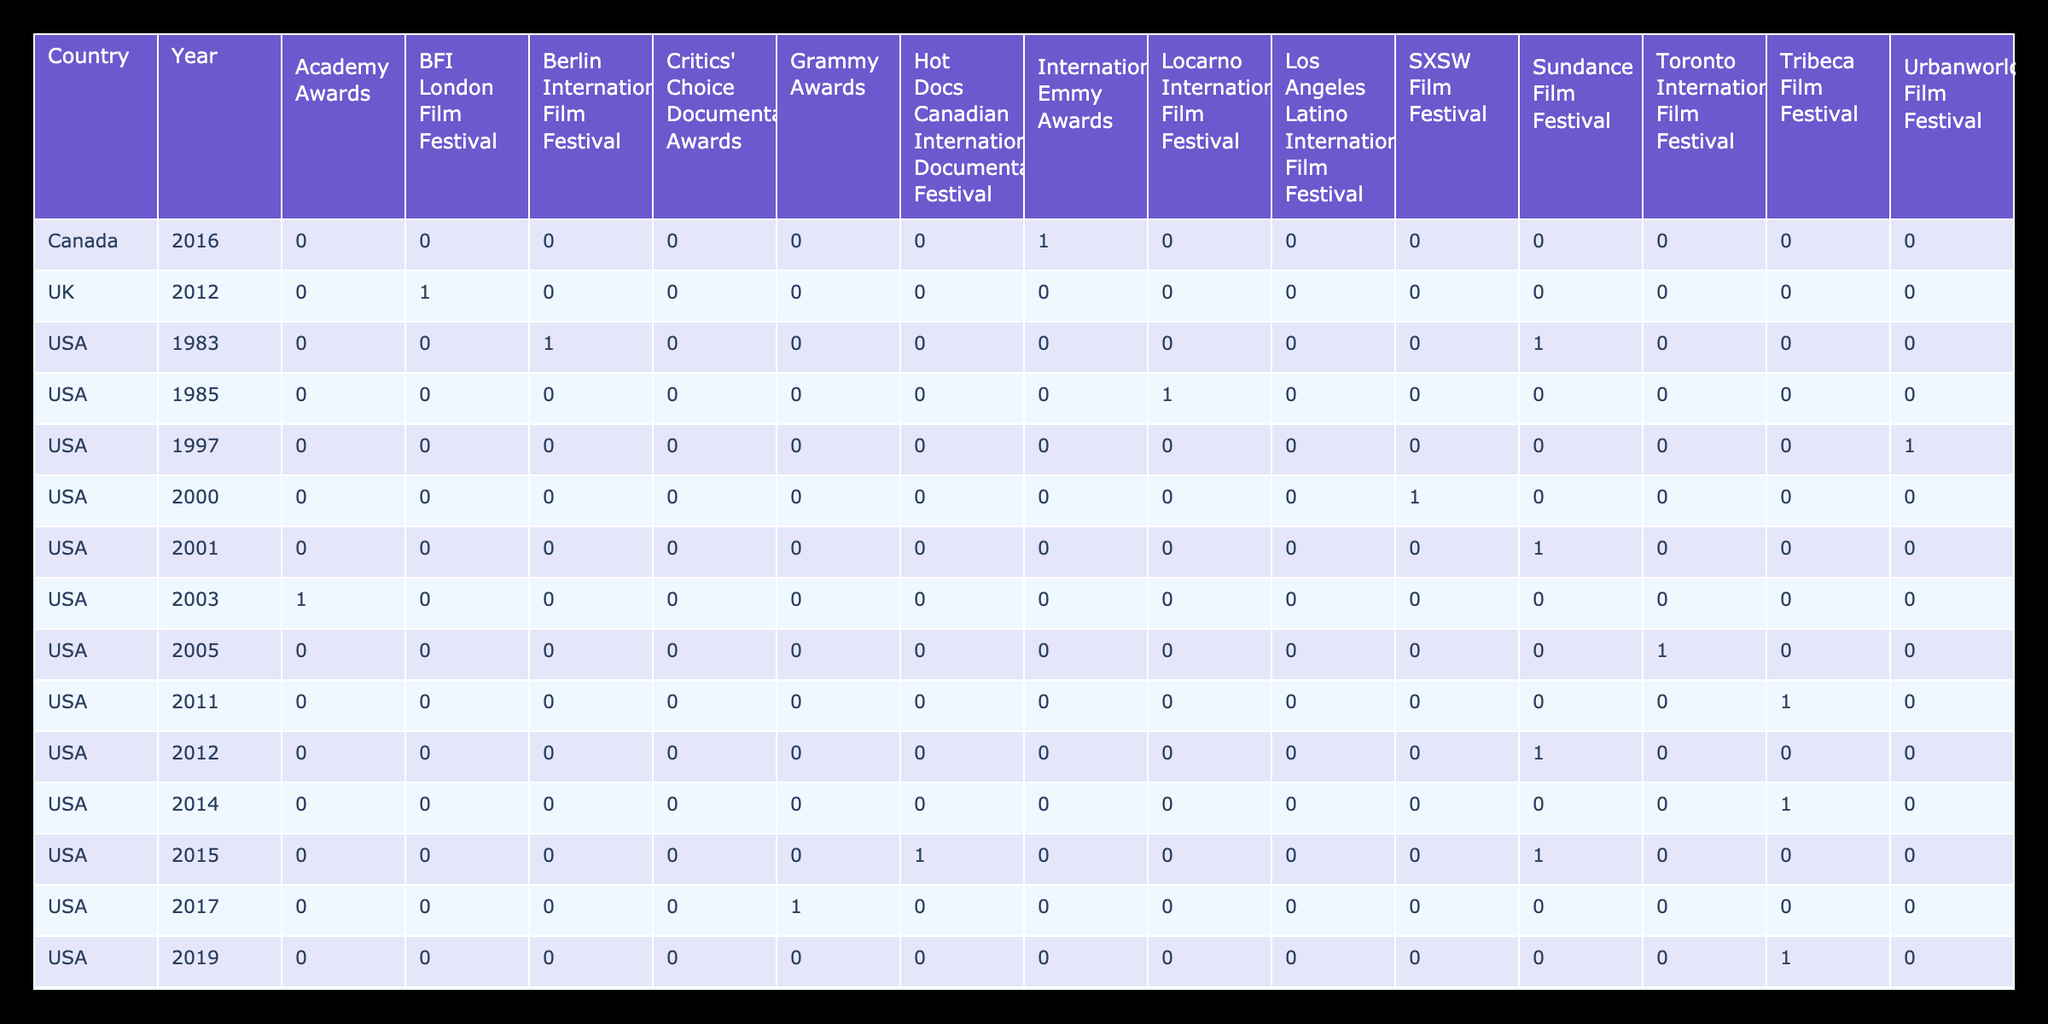What year did the film "Hip-Hop Evolution" win an award? The film "Hip-Hop Evolution" won an award in 2016, as indicated in the table under the Canada entry for the International Emmy Awards.
Answer: 2016 Which country had the highest number of awards for hip-hop documentaries? By examining the table, the USA has the highest number of wins across various festivals compared to Canada and the UK. Counting the awards under the USA, we find there are 11 instances.
Answer: USA Did the film "Tupac: Resurrection" receive a Best Documentary award? The entry for "Tupac: Resurrection" states that it was nominated for the Best Documentary Feature at the Academy Awards, which is not the same as winning the award. Thus, it did not win.
Answer: No What is the total count of awards won by hip-hop documentaries from the USA? Summing all instances in the USA category: 8 awards for Best Documentary, 1 for Grand Jury Prize Nomination, 1 for People's Choice Award, and others results in a total of 11 awards won by hip-hop documentaries from the USA.
Answer: 11 How many hip-hop documentaries were featured in the Tribeca Film Festival? The table lists three documentaries under the Tribeca Film Festival: "Beats Rhymes & Life," "Nas: Time Is Illmatic," and "Wu-Tang Clan: Of Mics and Men." Therefore, there are three entries.
Answer: 3 Was "Style Wars" nominated for any awards? The table shows that "Style Wars" received the Grand Jury Prize at the Sundance Film Festival, indicating it won an award.
Answer: Yes Which film had the most recent award listed, and what was it? The most recent film listed in the table is "Biggie: I Got a Story to Tell," awarded at the Critics' Choice Documentary Awards, indicating a win for Best Music Documentary in 2021.
Answer: Biggie: I Got a Story to Tell, Best Music Documentary Are there any documentaries from the UK that won awards? In the table, "Something From Nothing: The Art of Rap" is listed with a Grierson Award nomination but does not indicate it actually won an award, so there are no confirmed wins from the UK.
Answer: No 